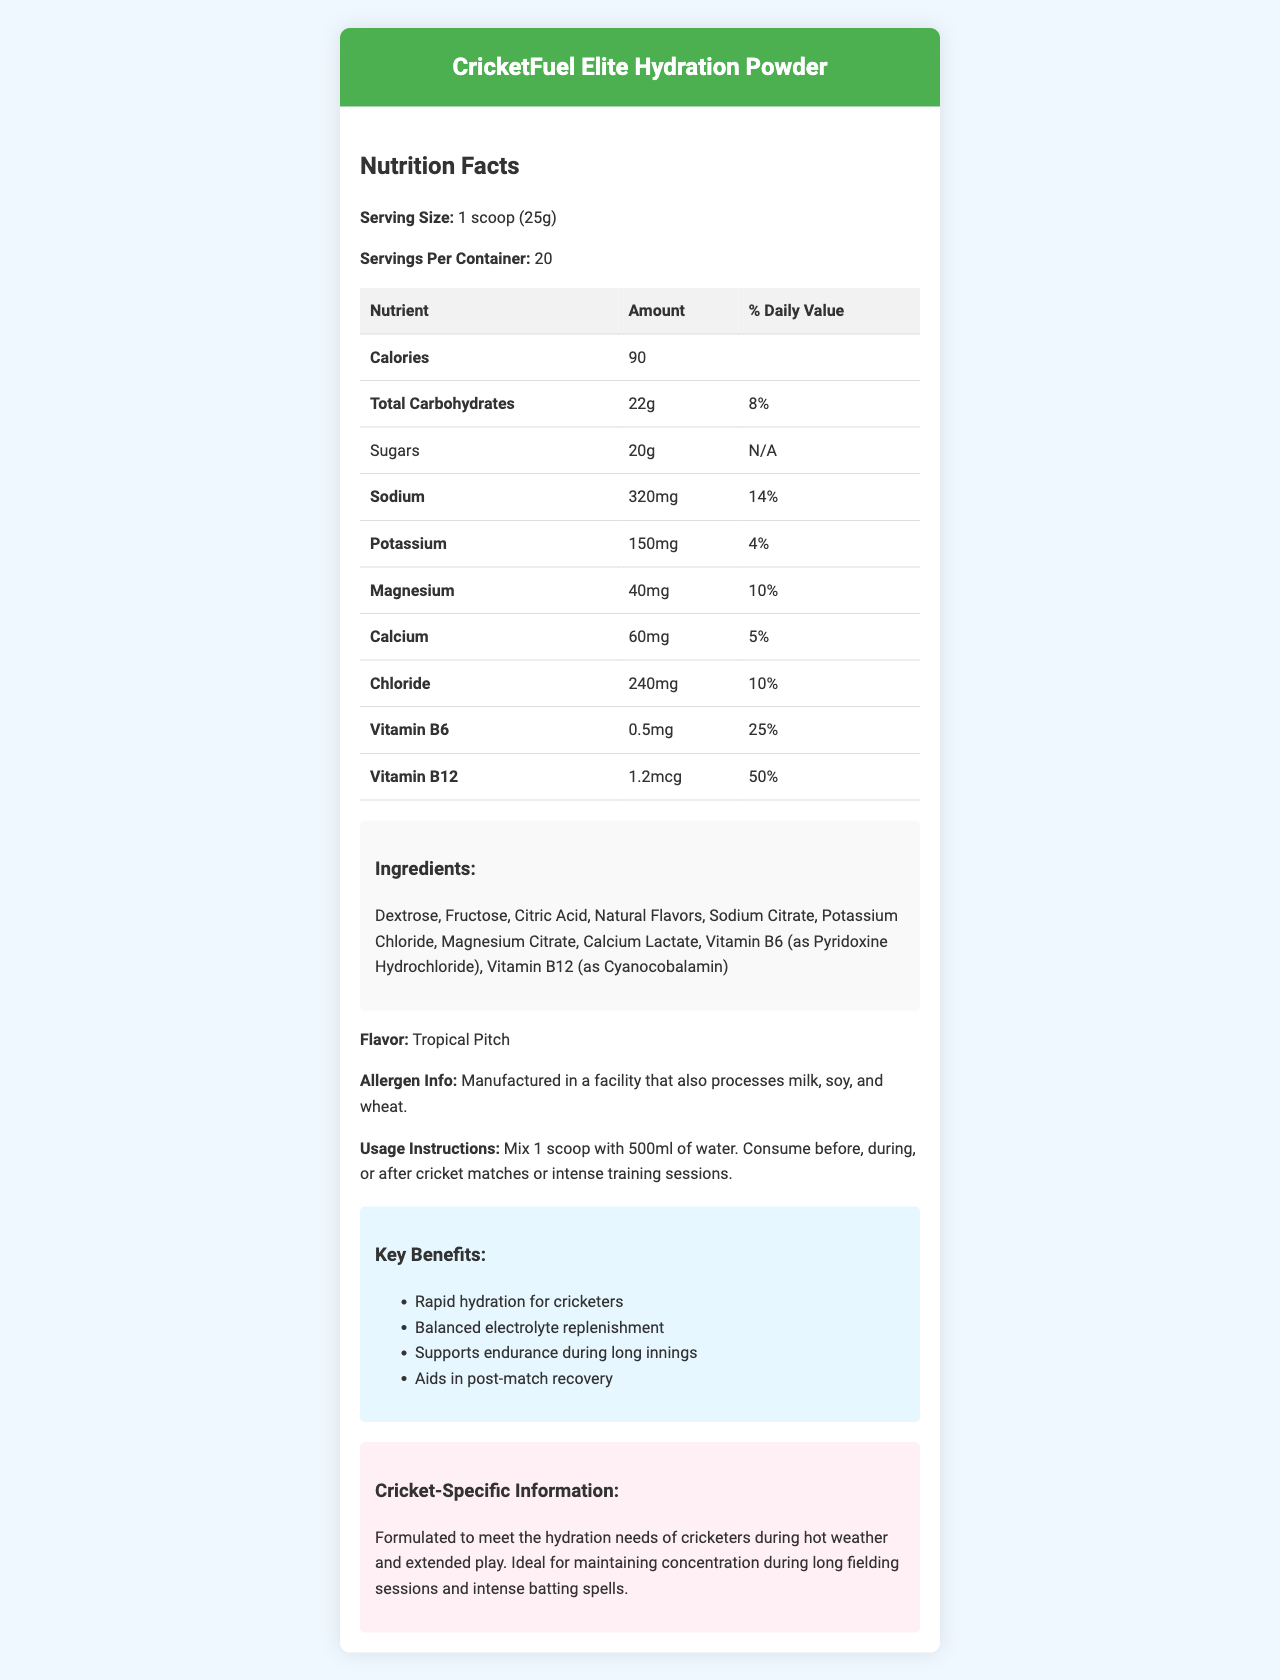what is the serving size? The serving size is mentioned at the beginning of the nutrition facts section.
Answer: 1 scoop (25g) how many calories are in one serving? The number of calories per serving is listed as 90 in the nutrition facts table.
Answer: 90 what is the amount of sodium per serving? The sodium content per serving is listed as 320mg in the nutrition facts table.
Answer: 320mg what percentage of the daily value is the total carbohydrate content? The daily value percentage for total carbohydrates is shown as 8% in the nutrition facts table.
Answer: 8% how much vitamin B6 is in each serving? The vitamin B6 content per serving is listed as 0.5mg in the nutrition facts table.
Answer: 0.5mg which electrolyte has the highest daily value percentage? 
A. Sodium 
B. Potassium 
C. Magnesium 
D. Calcium Sodium has the highest daily value percentage at 14%, as shown in the nutrition facts table.
Answer: A. Sodium what is the flavor of the CricketFuel Elite Hydration Powder? 
A. Citrus Splash 
B. Tropical Pitch 
C. Berry Blast 
D. Mint Refresh The flavor is stated as Tropical Pitch in the document.
Answer: B. Tropical Pitch is the hydration powder suitable for someone with a milk allergy? The allergen information states that it is manufactured in a facility that processes milk, soy, and wheat.
Answer: No what are the key benefits of using the CricketFuel Elite Hydration Powder? These benefits are listed in the key benefits section of the document.
Answer: Rapid hydration for cricketers, Balanced electrolyte replenishment, Supports endurance during long innings, Aids in post-match recovery why is this hydration powder specially formulated for cricketers? This information is provided in the cricket-specific information section of the document.
Answer: It meets the hydration needs of cricketers during hot weather and extended play, maintaining concentration during long fielding sessions and intense batting spells. which ingredient is primarily responsible for the hydration benefits of the powder? The ingredient list does not specify which ingredient is primarily responsible for hydration benefits, and more specific information is not provided visually in the document.
Answer: Cannot be determined how should the CricketFuel Elite Hydration Powder be consumed? The usage instructions provide the method of consumption and the timing for consuming the powder.
Answer: Mix 1 scoop with 500ml of water. Consume before, during, or after cricket matches or intense training sessions. describe the overall structure and key points of the Nutrition Facts Label for CricketFuel Elite Hydration Powder The document is structured to give a clear overview of nutritional content, ingredients, benefits, and specific usage instructions aimed at cricketers.
Answer: The document starts with the product's name and details like serving size and servings per container. It lists the nutrition facts, including calories, carbohydrates, sugars, and electrolytes like sodium, potassium, magnesium, calcium, and chloride. It also highlights vitamins B6 and B12. Ingredients, flavor, allergen information, and usage instructions are provided, followed by key benefits and cricket-specific information emphasizing the product's advantages for cricketers. 